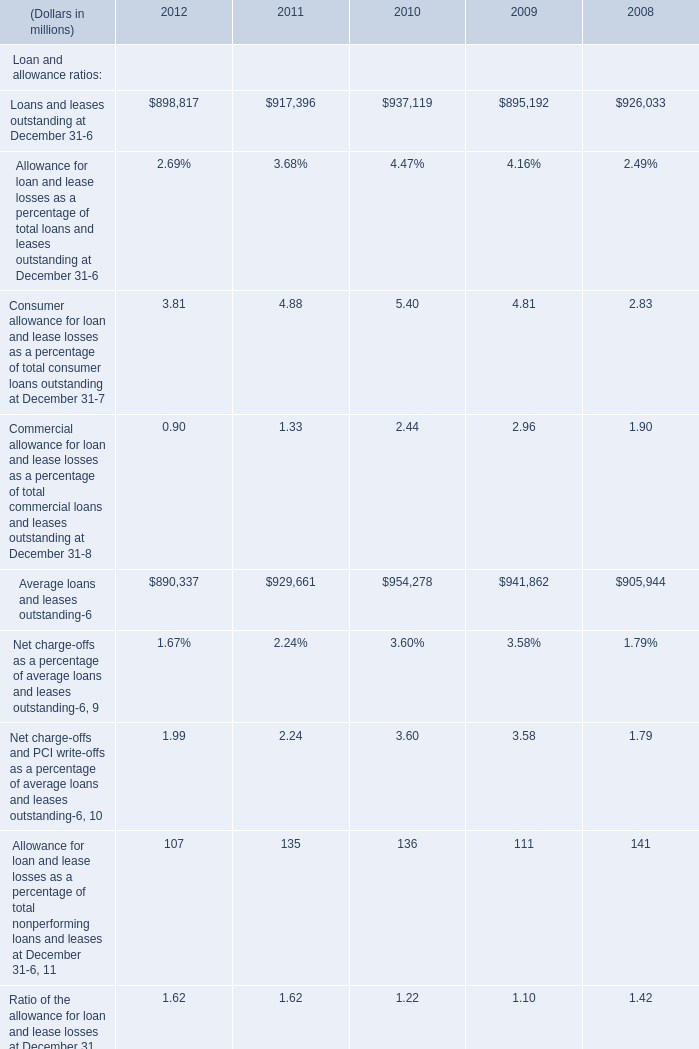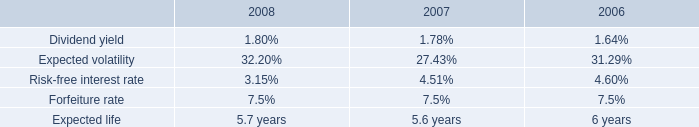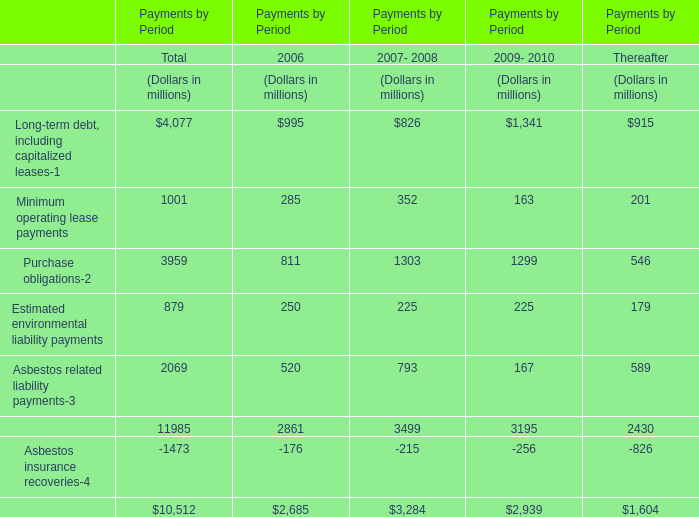What's the 2012 increasing rate of Average loans and leases outstanding? 
Computations: ((890337 - 929661) / 929661)
Answer: -0.0423. 